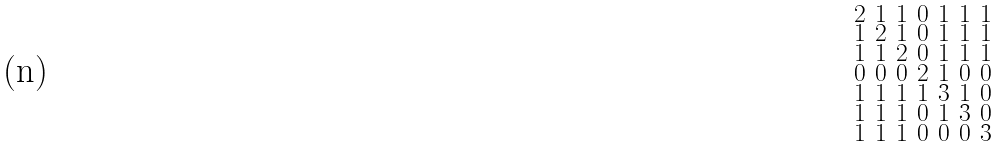<formula> <loc_0><loc_0><loc_500><loc_500>\begin{smallmatrix} 2 & 1 & 1 & 0 & 1 & 1 & 1 \\ 1 & 2 & 1 & 0 & 1 & 1 & 1 \\ 1 & 1 & 2 & 0 & 1 & 1 & 1 \\ 0 & 0 & 0 & 2 & 1 & 0 & 0 \\ 1 & 1 & 1 & 1 & 3 & 1 & 0 \\ 1 & 1 & 1 & 0 & 1 & 3 & 0 \\ 1 & 1 & 1 & 0 & 0 & 0 & 3 \end{smallmatrix}</formula> 